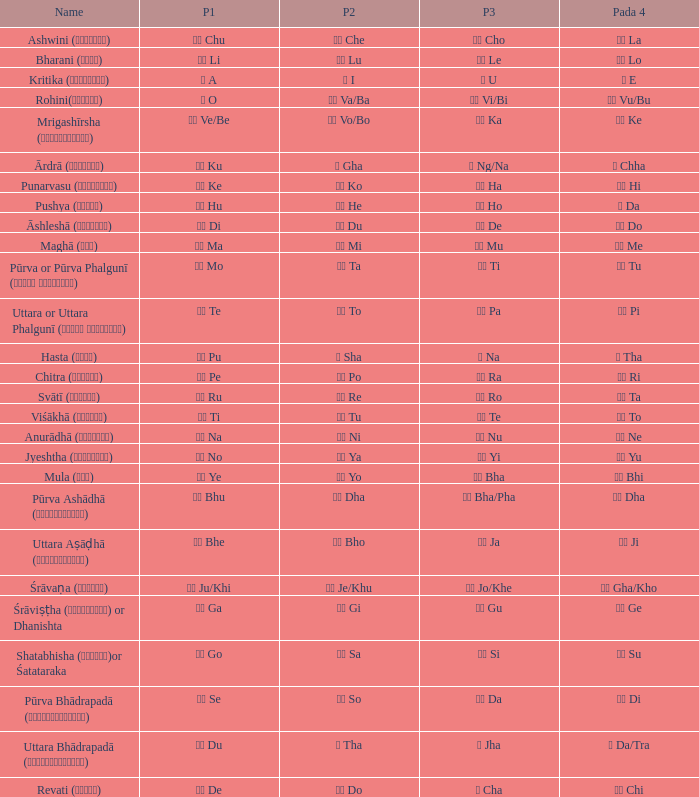What kind of Pada 4 has a Pada 1 of खी ju/khi? खो Gha/Kho. 